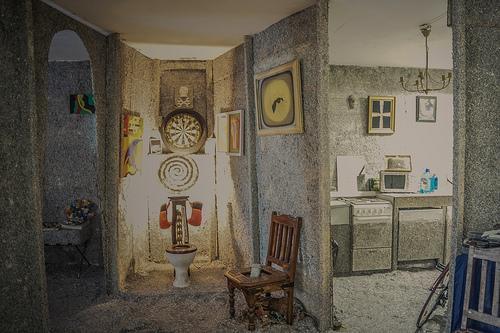How many toilets are in the picture?
Give a very brief answer. 1. How many chairs are visible?
Give a very brief answer. 1. 